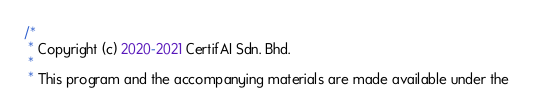<code> <loc_0><loc_0><loc_500><loc_500><_Java_>/*
 * Copyright (c) 2020-2021 CertifAI Sdn. Bhd.
 *
 * This program and the accompanying materials are made available under the</code> 